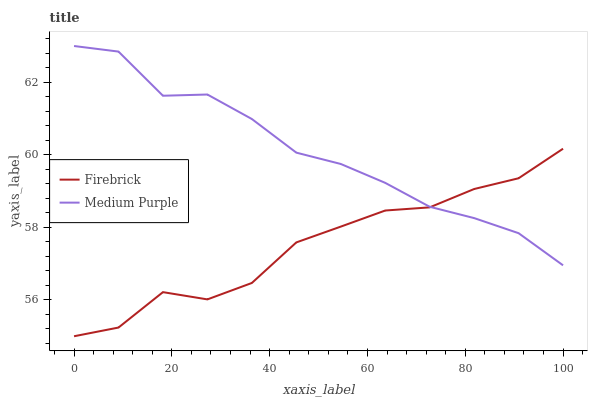Does Firebrick have the minimum area under the curve?
Answer yes or no. Yes. Does Medium Purple have the maximum area under the curve?
Answer yes or no. Yes. Does Firebrick have the maximum area under the curve?
Answer yes or no. No. Is Medium Purple the smoothest?
Answer yes or no. Yes. Is Firebrick the roughest?
Answer yes or no. Yes. Is Firebrick the smoothest?
Answer yes or no. No. Does Firebrick have the lowest value?
Answer yes or no. Yes. Does Medium Purple have the highest value?
Answer yes or no. Yes. Does Firebrick have the highest value?
Answer yes or no. No. Does Firebrick intersect Medium Purple?
Answer yes or no. Yes. Is Firebrick less than Medium Purple?
Answer yes or no. No. Is Firebrick greater than Medium Purple?
Answer yes or no. No. 